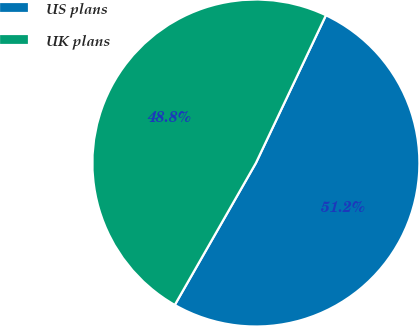Convert chart to OTSL. <chart><loc_0><loc_0><loc_500><loc_500><pie_chart><fcel>US plans<fcel>UK plans<nl><fcel>51.22%<fcel>48.78%<nl></chart> 